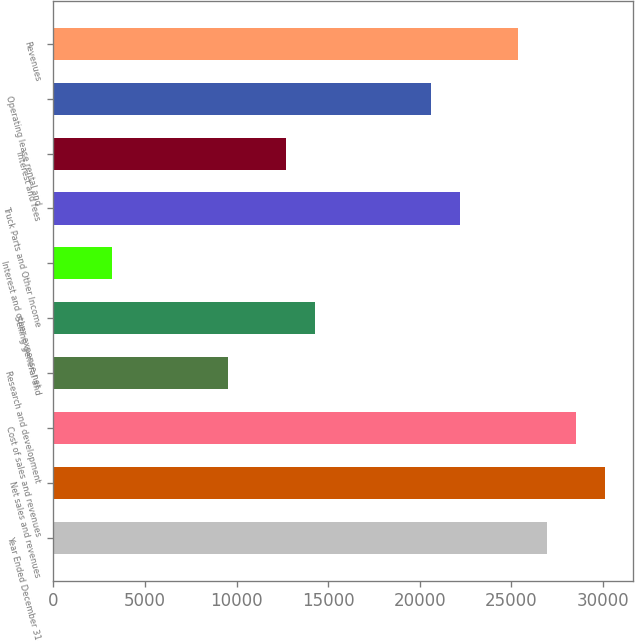<chart> <loc_0><loc_0><loc_500><loc_500><bar_chart><fcel>Year Ended December 31<fcel>Net sales and revenues<fcel>Cost of sales and revenues<fcel>Research and development<fcel>Selling general and<fcel>Interest and other expense net<fcel>Truck Parts and Other Income<fcel>Interest and fees<fcel>Operating lease rental and<fcel>Revenues<nl><fcel>26938.2<fcel>30107.2<fcel>28522.7<fcel>9508.54<fcel>14262.1<fcel>3170.5<fcel>22184.6<fcel>12677.6<fcel>20600.1<fcel>25353.6<nl></chart> 